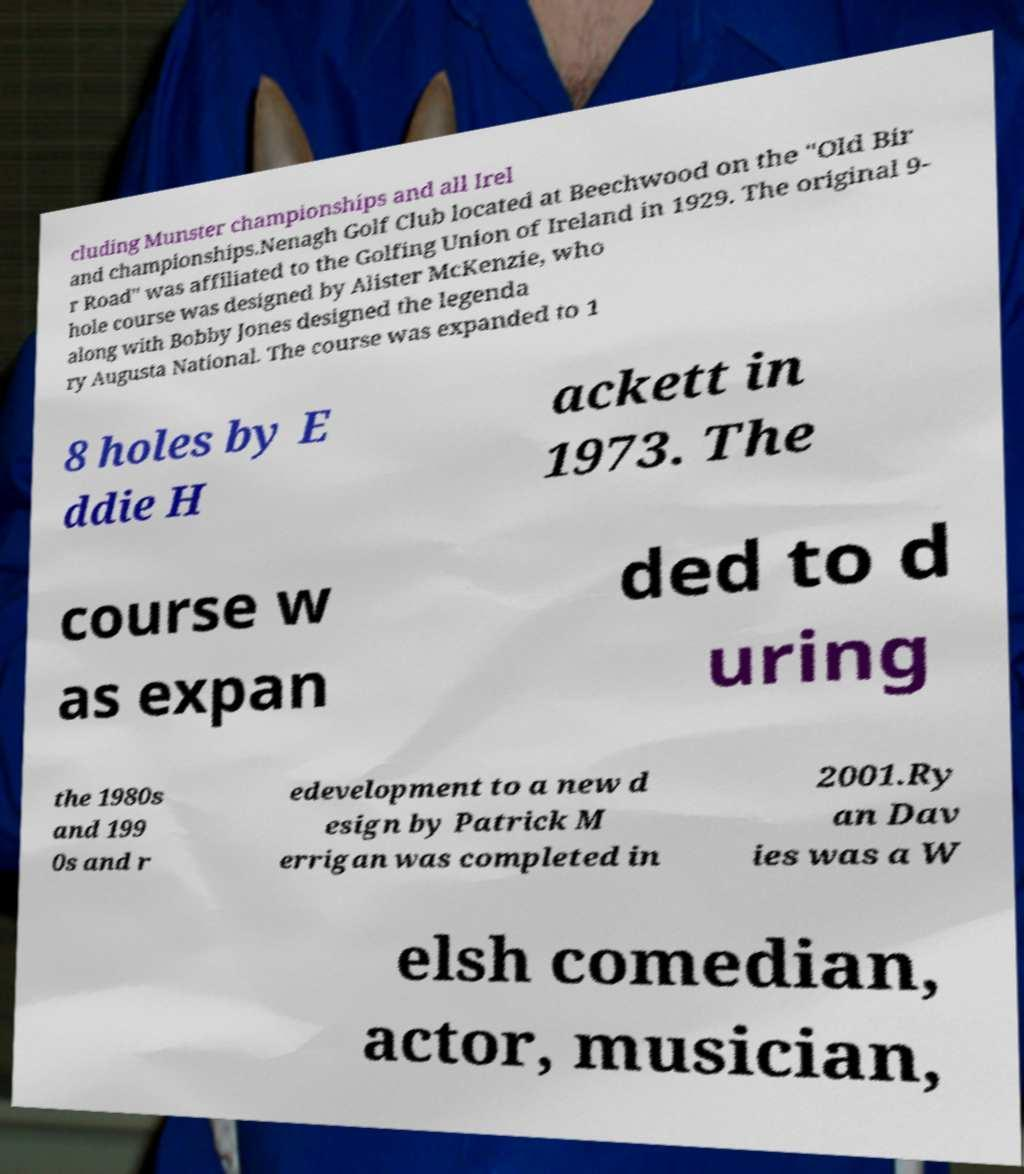Please read and relay the text visible in this image. What does it say? cluding Munster championships and all Irel and championships.Nenagh Golf Club located at Beechwood on the "Old Bir r Road" was affiliated to the Golfing Union of Ireland in 1929. The original 9- hole course was designed by Alister McKenzie, who along with Bobby Jones designed the legenda ry Augusta National. The course was expanded to 1 8 holes by E ddie H ackett in 1973. The course w as expan ded to d uring the 1980s and 199 0s and r edevelopment to a new d esign by Patrick M errigan was completed in 2001.Ry an Dav ies was a W elsh comedian, actor, musician, 